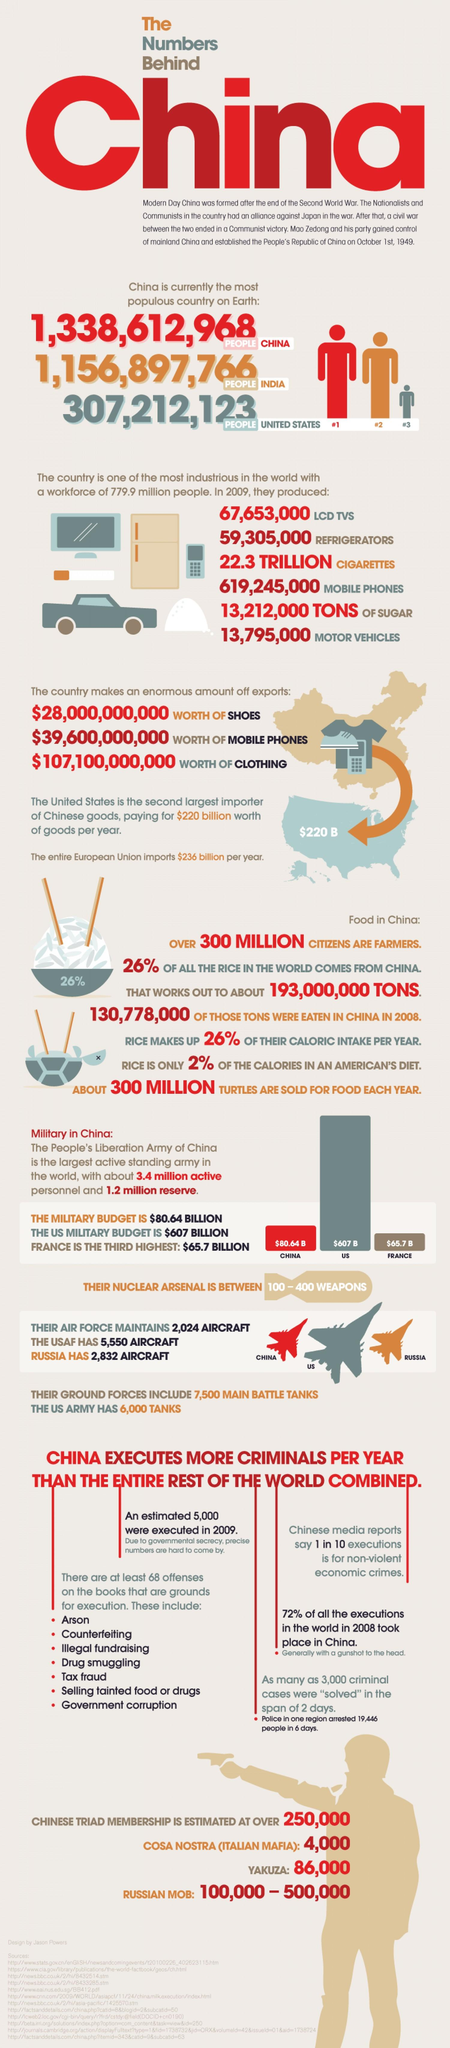Highlight a few significant elements in this photo. China exported 3 things. It is estimated that China produces approximately 6 things. According to a recent survey, only 26% of rice imported into the United States comes from China. 